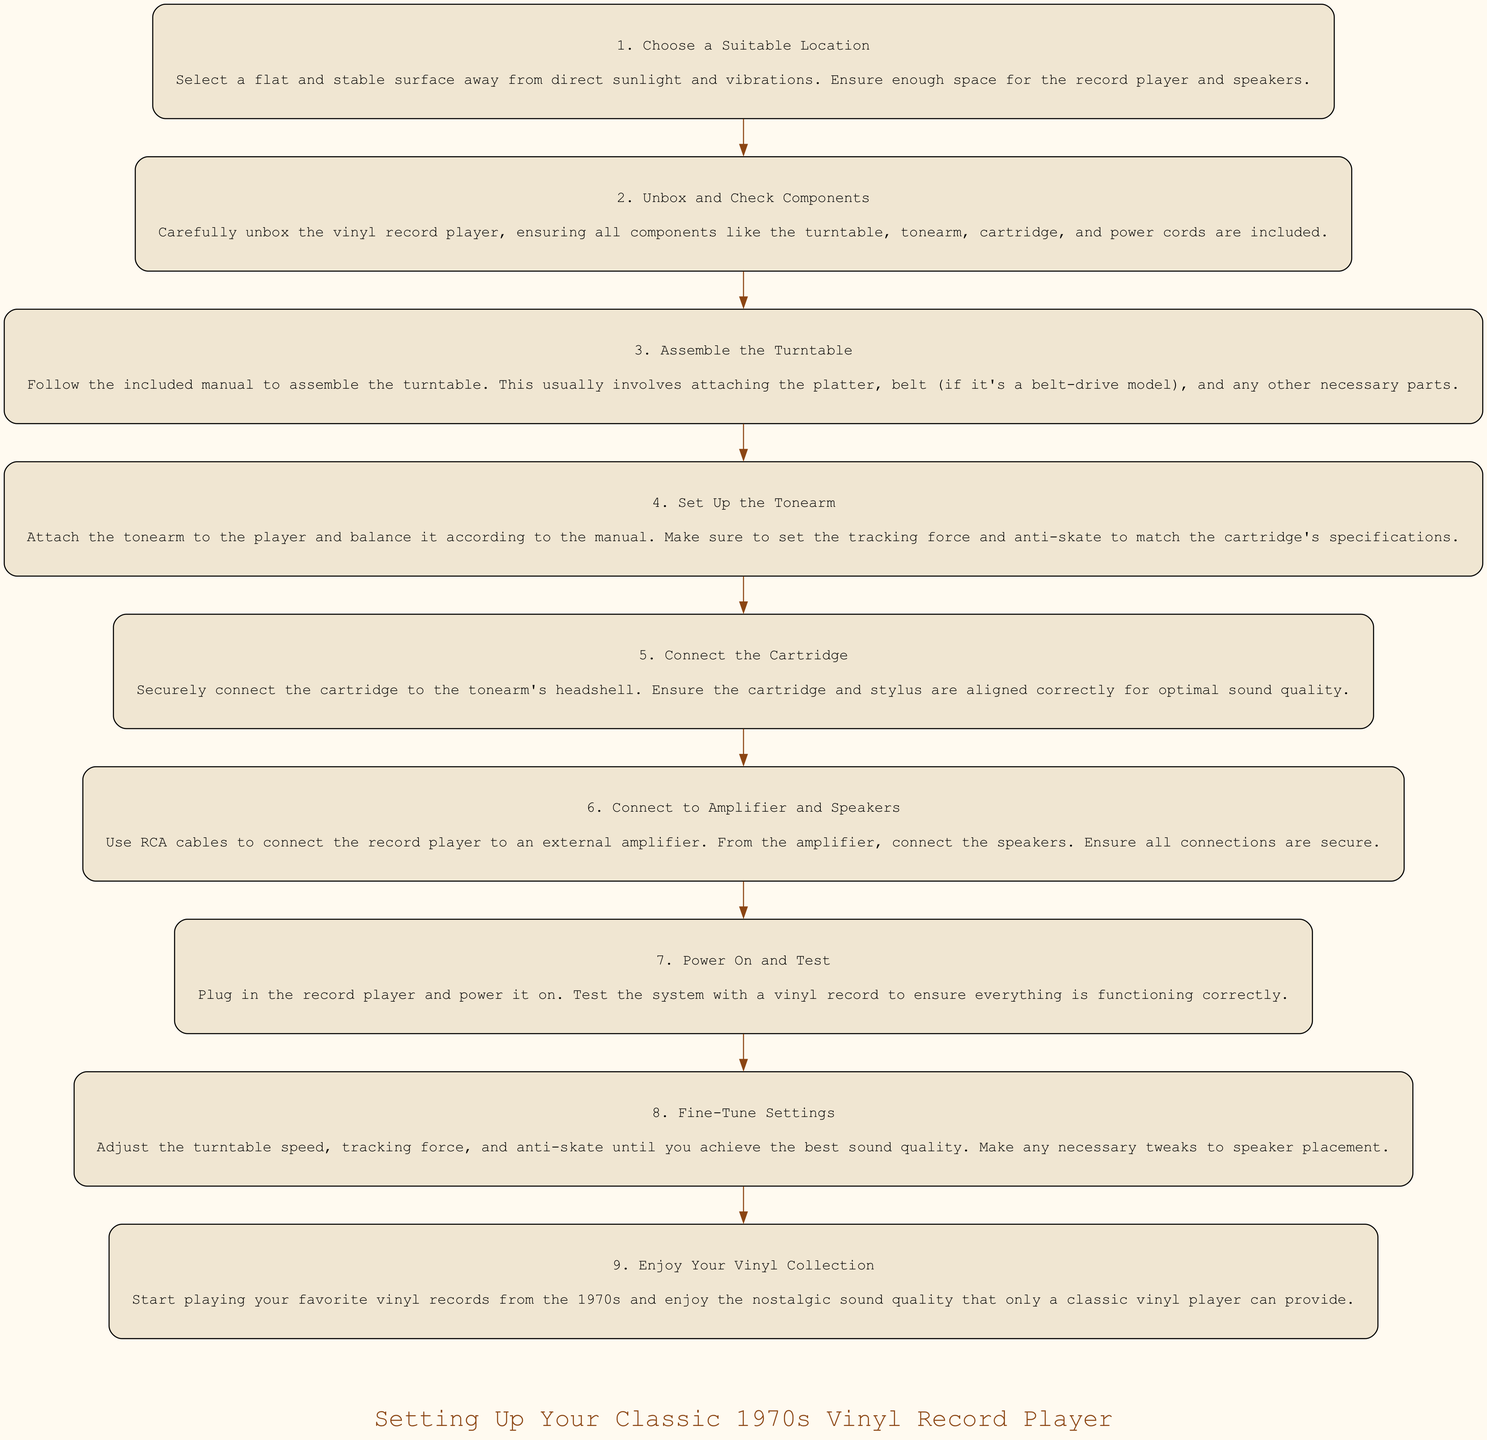What is the first step in the process? The first step in the flow chart is "Choose a Suitable Location". It is the first node listed in the sequence of steps to set up the vinyl record player.
Answer: Choose a Suitable Location How many total steps are in the process? The flow chart contains 9 steps, which can be counted by looking at each distinct node representing an instruction in the process.
Answer: 9 What components should be checked during unboxing? The instruction for "Unbox and Check Components" mentions checking components like the turntable, tonearm, cartridge, and power cords, which are explicitly listed in this step.
Answer: turntable, tonearm, cartridge, power cords Which step involves connecting to the speakers? The step "Connect to Amplifier and Speakers" specifically mentions making connections to speakers following the connection to an external amplifier, indicating this is the relevant step.
Answer: Connect to Amplifier and Speakers What is the last step of the process? The final step in the diagram is "Enjoy Your Vinyl Collection", which is the last node in the sequence, indicating it comes after all setup activities are completed.
Answer: Enjoy Your Vinyl Collection What is the purpose of balancing the tonearm? In the step "Set Up the Tonearm", it specifies that the tonearm must be balanced according to the manual to ensure proper tracking force and anti-skate settings, highlighting its importance in setup.
Answer: proper tracking and anti-skate settings What needs to be adjusted for optimal sound quality? The step "Fine-Tune Settings" indicates that adjustments should be made to the turntable speed, tracking force, and anti-skate, all necessary for achieving the best sound quality from the player.
Answer: turntable speed, tracking force, anti-skate What should be done after powering on the record player? According to the flow chart, after powering on the record player, the next step is to test the system with a vinyl record, ensuring everything is functioning correctly.
Answer: Test the system with a vinyl record How are the components connected from the record player to the speakers? The step "Connect to Amplifier and Speakers" details the use of RCA cables to connect the record player to an external amplifier and then to the speakers, indicating a two-step connection process.
Answer: RCA cables to the amplifier then to the speakers 